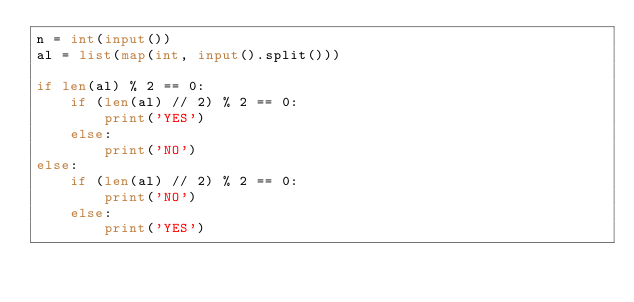<code> <loc_0><loc_0><loc_500><loc_500><_Python_>n = int(input())
al = list(map(int, input().split()))

if len(al) % 2 == 0:
    if (len(al) // 2) % 2 == 0:
        print('YES')
    else:
        print('NO')
else:
    if (len(al) // 2) % 2 == 0:
        print('NO')
    else:
        print('YES')
</code> 